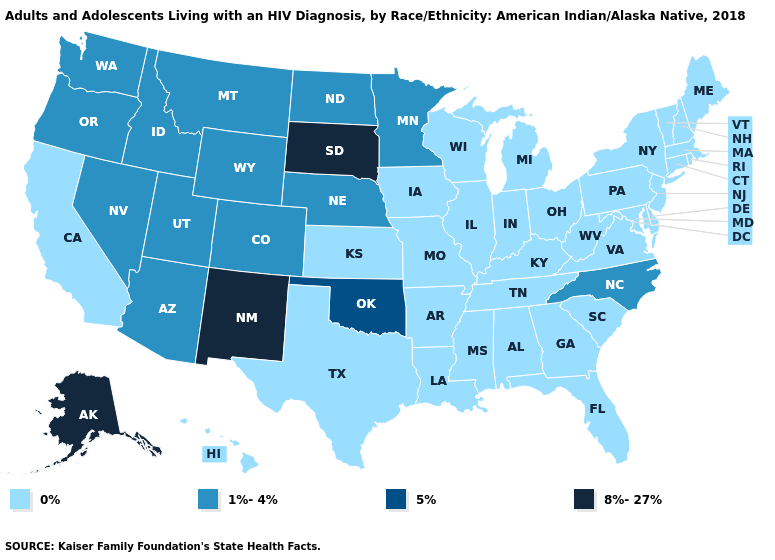What is the value of Washington?
Answer briefly. 1%-4%. Does Utah have the highest value in the USA?
Give a very brief answer. No. Does the first symbol in the legend represent the smallest category?
Short answer required. Yes. Name the states that have a value in the range 8%-27%?
Answer briefly. Alaska, New Mexico, South Dakota. Which states have the lowest value in the USA?
Quick response, please. Alabama, Arkansas, California, Connecticut, Delaware, Florida, Georgia, Hawaii, Illinois, Indiana, Iowa, Kansas, Kentucky, Louisiana, Maine, Maryland, Massachusetts, Michigan, Mississippi, Missouri, New Hampshire, New Jersey, New York, Ohio, Pennsylvania, Rhode Island, South Carolina, Tennessee, Texas, Vermont, Virginia, West Virginia, Wisconsin. Name the states that have a value in the range 8%-27%?
Concise answer only. Alaska, New Mexico, South Dakota. Is the legend a continuous bar?
Short answer required. No. Which states have the highest value in the USA?
Quick response, please. Alaska, New Mexico, South Dakota. Name the states that have a value in the range 0%?
Be succinct. Alabama, Arkansas, California, Connecticut, Delaware, Florida, Georgia, Hawaii, Illinois, Indiana, Iowa, Kansas, Kentucky, Louisiana, Maine, Maryland, Massachusetts, Michigan, Mississippi, Missouri, New Hampshire, New Jersey, New York, Ohio, Pennsylvania, Rhode Island, South Carolina, Tennessee, Texas, Vermont, Virginia, West Virginia, Wisconsin. Does Idaho have the highest value in the USA?
Be succinct. No. Name the states that have a value in the range 8%-27%?
Quick response, please. Alaska, New Mexico, South Dakota. Which states have the lowest value in the Northeast?
Give a very brief answer. Connecticut, Maine, Massachusetts, New Hampshire, New Jersey, New York, Pennsylvania, Rhode Island, Vermont. Does the map have missing data?
Concise answer only. No. Does Arkansas have a higher value than Colorado?
Give a very brief answer. No. 